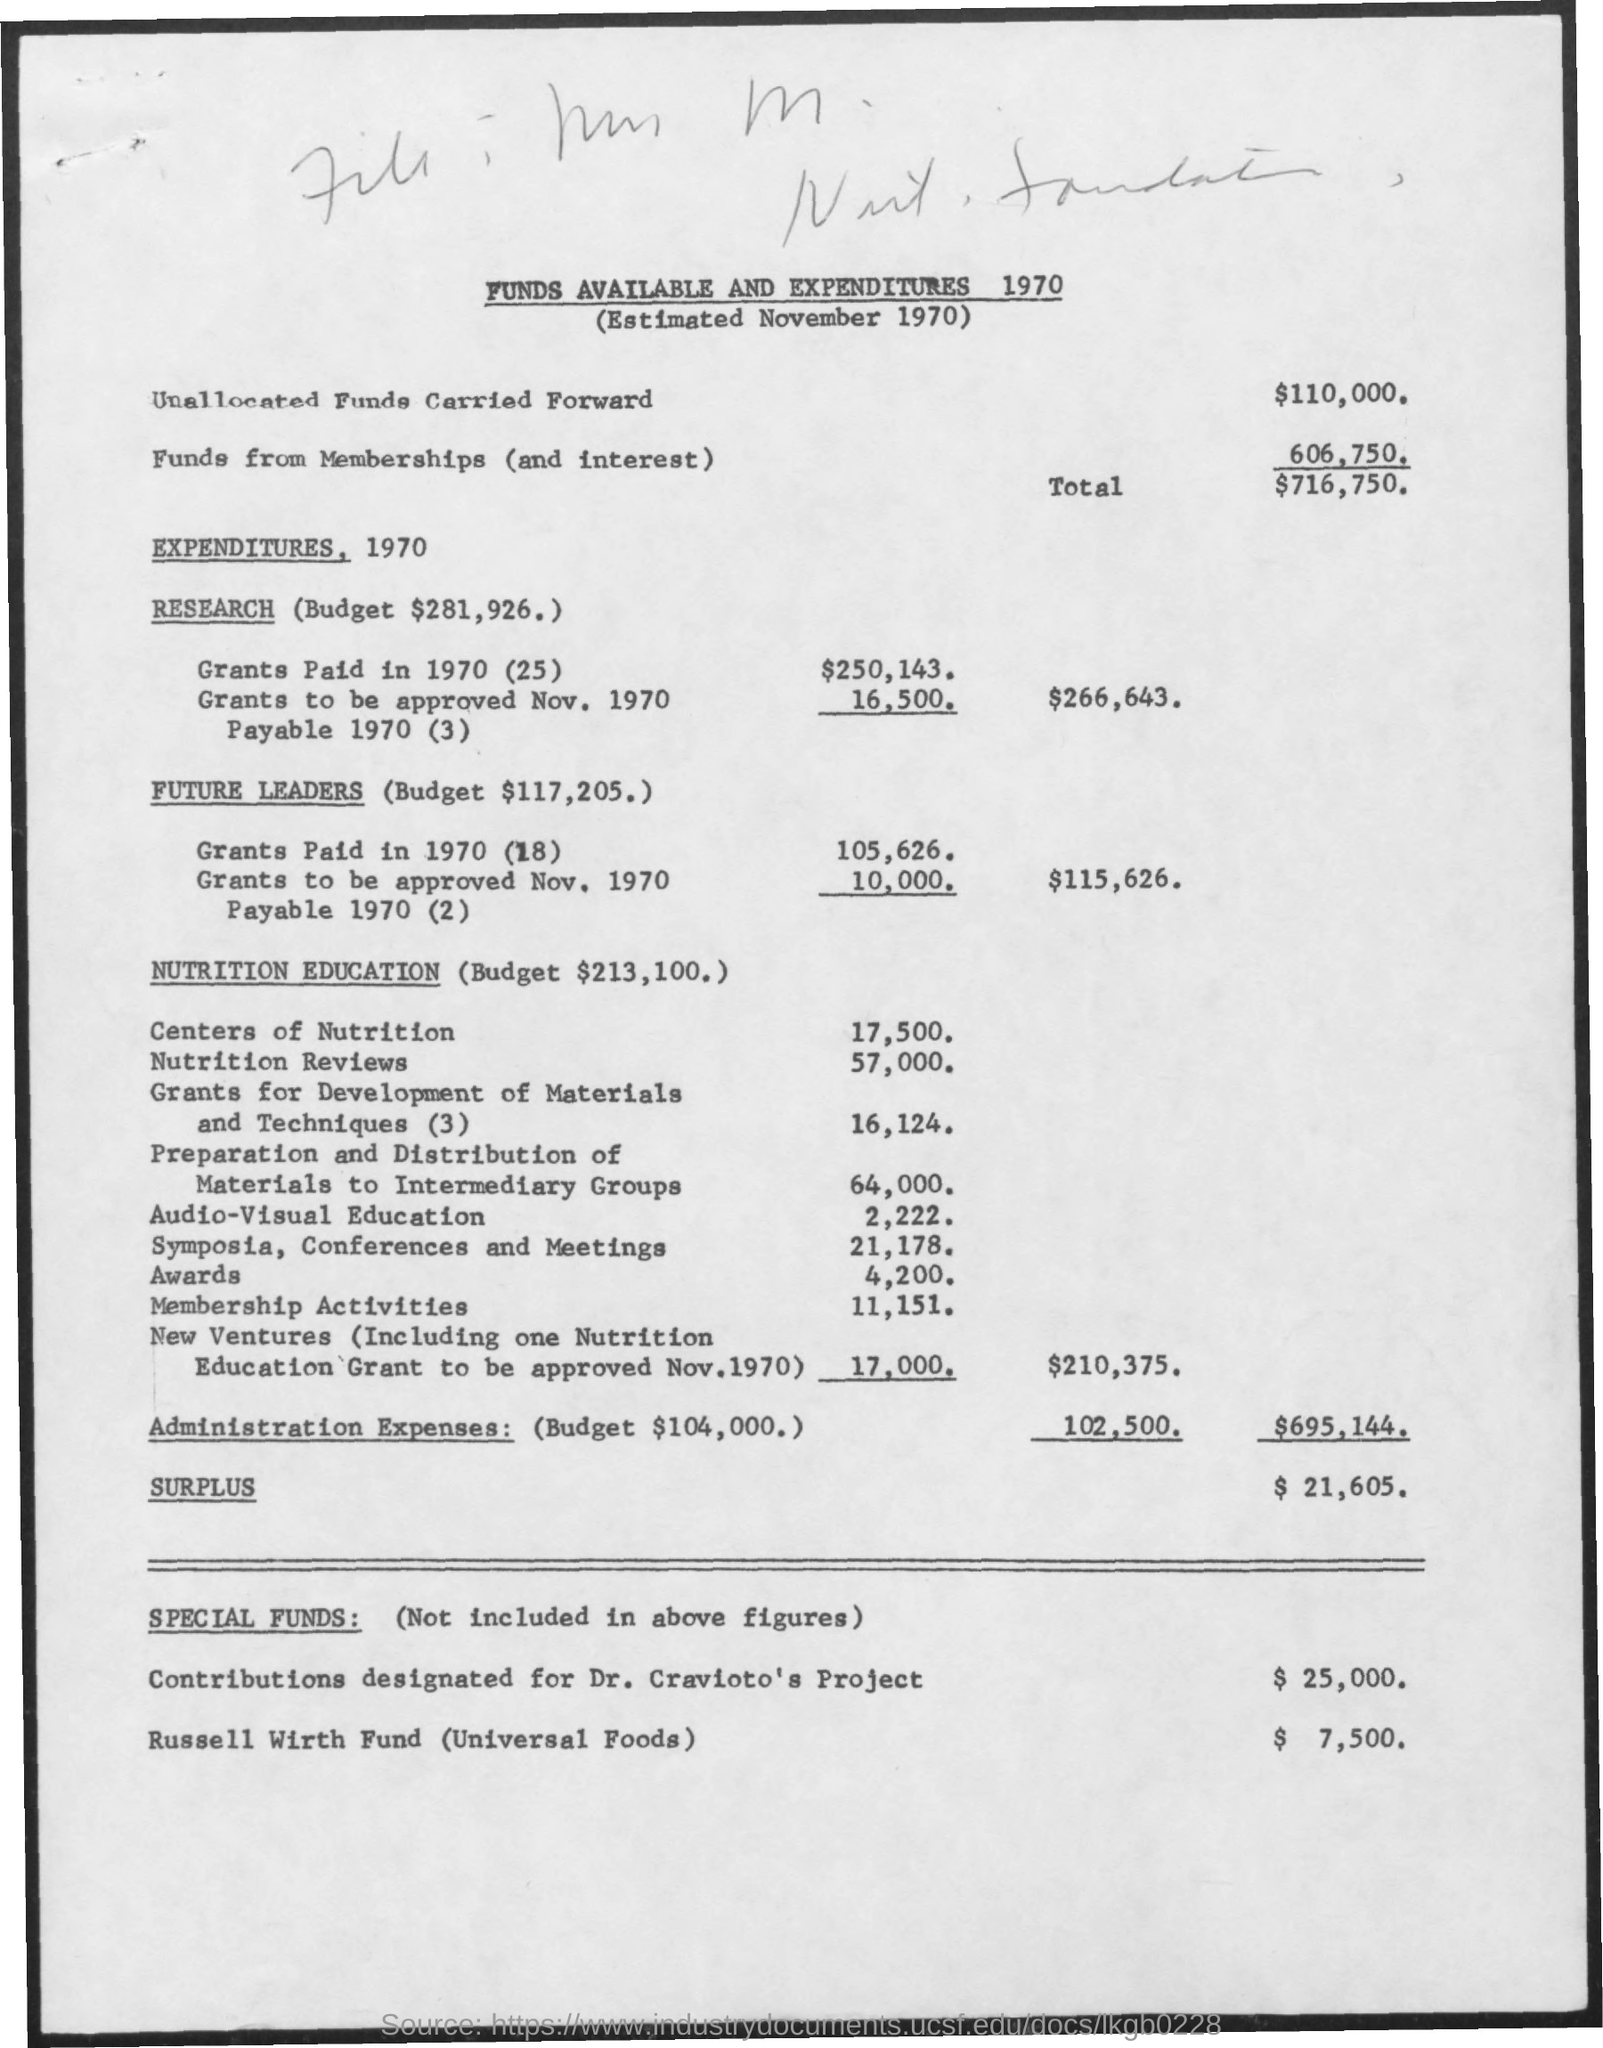Specify some key components in this picture. The amount mentioned for Russell Wirth Fund is $7,500. The budget allocated for nutrition education is $213,100. The budget for administration expenses is mentioned to be $104,000. The amount of unallocated funds carried forward is mentioned as $110,000. The total amount mentioned is $716,750. 